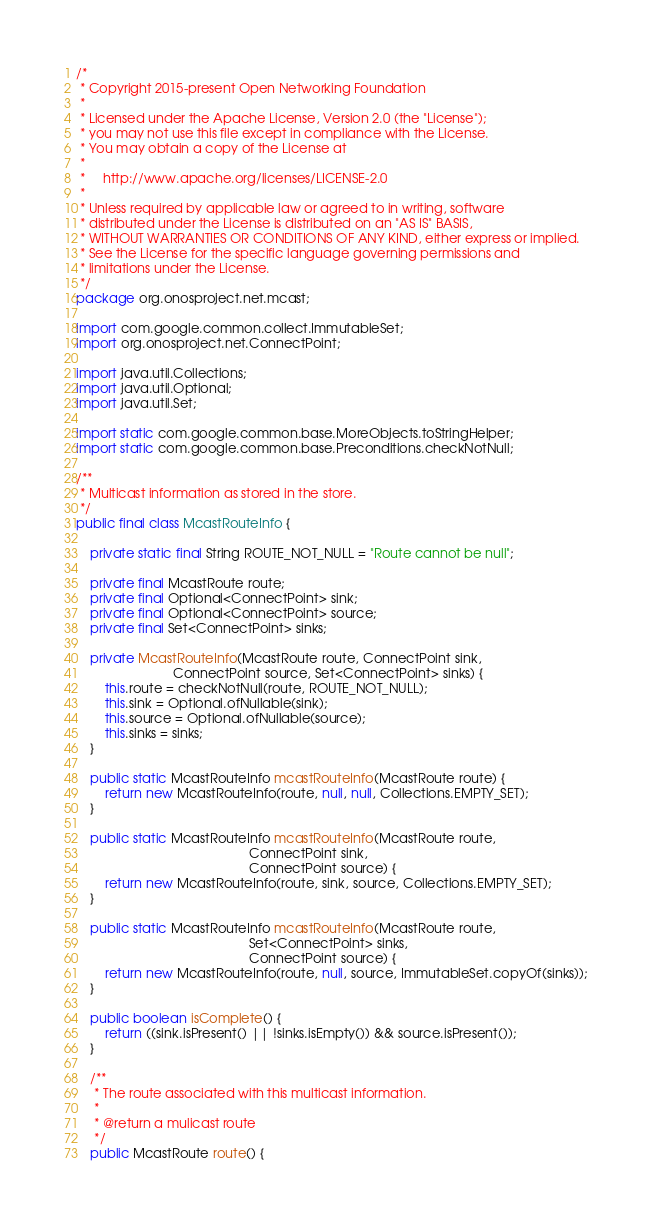Convert code to text. <code><loc_0><loc_0><loc_500><loc_500><_Java_>/*
 * Copyright 2015-present Open Networking Foundation
 *
 * Licensed under the Apache License, Version 2.0 (the "License");
 * you may not use this file except in compliance with the License.
 * You may obtain a copy of the License at
 *
 *     http://www.apache.org/licenses/LICENSE-2.0
 *
 * Unless required by applicable law or agreed to in writing, software
 * distributed under the License is distributed on an "AS IS" BASIS,
 * WITHOUT WARRANTIES OR CONDITIONS OF ANY KIND, either express or implied.
 * See the License for the specific language governing permissions and
 * limitations under the License.
 */
package org.onosproject.net.mcast;

import com.google.common.collect.ImmutableSet;
import org.onosproject.net.ConnectPoint;

import java.util.Collections;
import java.util.Optional;
import java.util.Set;

import static com.google.common.base.MoreObjects.toStringHelper;
import static com.google.common.base.Preconditions.checkNotNull;

/**
 * Multicast information as stored in the store.
 */
public final class McastRouteInfo {

    private static final String ROUTE_NOT_NULL = "Route cannot be null";

    private final McastRoute route;
    private final Optional<ConnectPoint> sink;
    private final Optional<ConnectPoint> source;
    private final Set<ConnectPoint> sinks;

    private McastRouteInfo(McastRoute route, ConnectPoint sink,
                           ConnectPoint source, Set<ConnectPoint> sinks) {
        this.route = checkNotNull(route, ROUTE_NOT_NULL);
        this.sink = Optional.ofNullable(sink);
        this.source = Optional.ofNullable(source);
        this.sinks = sinks;
    }

    public static McastRouteInfo mcastRouteInfo(McastRoute route) {
        return new McastRouteInfo(route, null, null, Collections.EMPTY_SET);
    }

    public static McastRouteInfo mcastRouteInfo(McastRoute route,
                                                ConnectPoint sink,
                                                ConnectPoint source) {
        return new McastRouteInfo(route, sink, source, Collections.EMPTY_SET);
    }

    public static McastRouteInfo mcastRouteInfo(McastRoute route,
                                                Set<ConnectPoint> sinks,
                                                ConnectPoint source) {
        return new McastRouteInfo(route, null, source, ImmutableSet.copyOf(sinks));
    }

    public boolean isComplete() {
        return ((sink.isPresent() || !sinks.isEmpty()) && source.isPresent());
    }

    /**
     * The route associated with this multicast information.
     *
     * @return a mulicast route
     */
    public McastRoute route() {</code> 